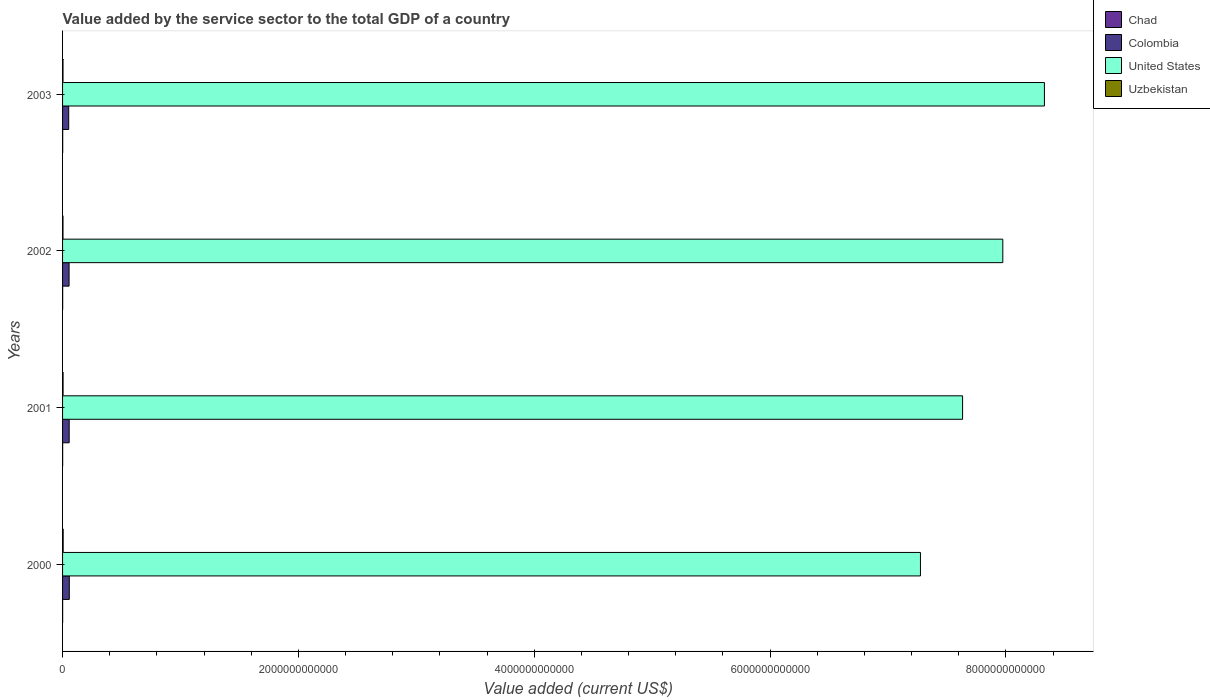How many different coloured bars are there?
Your answer should be compact. 4. How many groups of bars are there?
Your response must be concise. 4. Are the number of bars per tick equal to the number of legend labels?
Provide a short and direct response. Yes. Are the number of bars on each tick of the Y-axis equal?
Give a very brief answer. Yes. What is the value added by the service sector to the total GDP in Uzbekistan in 2002?
Ensure brevity in your answer.  3.72e+09. Across all years, what is the maximum value added by the service sector to the total GDP in United States?
Provide a succinct answer. 8.33e+12. Across all years, what is the minimum value added by the service sector to the total GDP in United States?
Make the answer very short. 7.28e+12. What is the total value added by the service sector to the total GDP in Uzbekistan in the graph?
Your answer should be very brief. 1.70e+1. What is the difference between the value added by the service sector to the total GDP in Chad in 2001 and that in 2003?
Ensure brevity in your answer.  -3.71e+08. What is the difference between the value added by the service sector to the total GDP in United States in 2003 and the value added by the service sector to the total GDP in Chad in 2002?
Keep it short and to the point. 8.33e+12. What is the average value added by the service sector to the total GDP in United States per year?
Make the answer very short. 7.80e+12. In the year 2000, what is the difference between the value added by the service sector to the total GDP in Chad and value added by the service sector to the total GDP in Colombia?
Provide a succinct answer. -5.65e+1. What is the ratio of the value added by the service sector to the total GDP in Colombia in 2002 to that in 2003?
Offer a very short reply. 1.06. Is the value added by the service sector to the total GDP in United States in 2002 less than that in 2003?
Make the answer very short. Yes. What is the difference between the highest and the second highest value added by the service sector to the total GDP in United States?
Give a very brief answer. 3.53e+11. What is the difference between the highest and the lowest value added by the service sector to the total GDP in Colombia?
Keep it short and to the point. 5.15e+09. In how many years, is the value added by the service sector to the total GDP in Chad greater than the average value added by the service sector to the total GDP in Chad taken over all years?
Your response must be concise. 2. Is it the case that in every year, the sum of the value added by the service sector to the total GDP in United States and value added by the service sector to the total GDP in Uzbekistan is greater than the sum of value added by the service sector to the total GDP in Colombia and value added by the service sector to the total GDP in Chad?
Provide a succinct answer. Yes. What does the 2nd bar from the top in 2002 represents?
Provide a succinct answer. United States. How many bars are there?
Offer a very short reply. 16. Are all the bars in the graph horizontal?
Your answer should be very brief. Yes. What is the difference between two consecutive major ticks on the X-axis?
Your answer should be compact. 2.00e+12. Does the graph contain any zero values?
Offer a terse response. No. Does the graph contain grids?
Your answer should be compact. No. Where does the legend appear in the graph?
Ensure brevity in your answer.  Top right. How many legend labels are there?
Provide a short and direct response. 4. What is the title of the graph?
Ensure brevity in your answer.  Value added by the service sector to the total GDP of a country. What is the label or title of the X-axis?
Give a very brief answer. Value added (current US$). What is the Value added (current US$) of Chad in 2000?
Keep it short and to the point. 6.17e+08. What is the Value added (current US$) in Colombia in 2000?
Your response must be concise. 5.71e+1. What is the Value added (current US$) of United States in 2000?
Keep it short and to the point. 7.28e+12. What is the Value added (current US$) of Uzbekistan in 2000?
Keep it short and to the point. 5.12e+09. What is the Value added (current US$) of Chad in 2001?
Your response must be concise. 7.35e+08. What is the Value added (current US$) of Colombia in 2001?
Ensure brevity in your answer.  5.61e+1. What is the Value added (current US$) of United States in 2001?
Your answer should be compact. 7.63e+12. What is the Value added (current US$) of Uzbekistan in 2001?
Offer a terse response. 4.36e+09. What is the Value added (current US$) of Chad in 2002?
Give a very brief answer. 8.73e+08. What is the Value added (current US$) of Colombia in 2002?
Your answer should be very brief. 5.53e+1. What is the Value added (current US$) of United States in 2002?
Your response must be concise. 7.97e+12. What is the Value added (current US$) of Uzbekistan in 2002?
Offer a terse response. 3.72e+09. What is the Value added (current US$) of Chad in 2003?
Provide a succinct answer. 1.11e+09. What is the Value added (current US$) of Colombia in 2003?
Keep it short and to the point. 5.20e+1. What is the Value added (current US$) in United States in 2003?
Keep it short and to the point. 8.33e+12. What is the Value added (current US$) of Uzbekistan in 2003?
Your answer should be compact. 3.79e+09. Across all years, what is the maximum Value added (current US$) in Chad?
Keep it short and to the point. 1.11e+09. Across all years, what is the maximum Value added (current US$) of Colombia?
Offer a very short reply. 5.71e+1. Across all years, what is the maximum Value added (current US$) of United States?
Keep it short and to the point. 8.33e+12. Across all years, what is the maximum Value added (current US$) in Uzbekistan?
Your answer should be compact. 5.12e+09. Across all years, what is the minimum Value added (current US$) in Chad?
Your answer should be very brief. 6.17e+08. Across all years, what is the minimum Value added (current US$) in Colombia?
Ensure brevity in your answer.  5.20e+1. Across all years, what is the minimum Value added (current US$) in United States?
Offer a terse response. 7.28e+12. Across all years, what is the minimum Value added (current US$) of Uzbekistan?
Your response must be concise. 3.72e+09. What is the total Value added (current US$) in Chad in the graph?
Give a very brief answer. 3.33e+09. What is the total Value added (current US$) of Colombia in the graph?
Give a very brief answer. 2.21e+11. What is the total Value added (current US$) of United States in the graph?
Offer a terse response. 3.12e+13. What is the total Value added (current US$) in Uzbekistan in the graph?
Provide a short and direct response. 1.70e+1. What is the difference between the Value added (current US$) in Chad in 2000 and that in 2001?
Give a very brief answer. -1.18e+08. What is the difference between the Value added (current US$) in Colombia in 2000 and that in 2001?
Ensure brevity in your answer.  9.92e+08. What is the difference between the Value added (current US$) in United States in 2000 and that in 2001?
Provide a succinct answer. -3.57e+11. What is the difference between the Value added (current US$) of Uzbekistan in 2000 and that in 2001?
Offer a terse response. 7.60e+08. What is the difference between the Value added (current US$) of Chad in 2000 and that in 2002?
Offer a terse response. -2.56e+08. What is the difference between the Value added (current US$) of Colombia in 2000 and that in 2002?
Make the answer very short. 1.84e+09. What is the difference between the Value added (current US$) of United States in 2000 and that in 2002?
Provide a short and direct response. -6.99e+11. What is the difference between the Value added (current US$) in Uzbekistan in 2000 and that in 2002?
Keep it short and to the point. 1.39e+09. What is the difference between the Value added (current US$) of Chad in 2000 and that in 2003?
Offer a terse response. -4.88e+08. What is the difference between the Value added (current US$) in Colombia in 2000 and that in 2003?
Your answer should be compact. 5.15e+09. What is the difference between the Value added (current US$) of United States in 2000 and that in 2003?
Keep it short and to the point. -1.05e+12. What is the difference between the Value added (current US$) in Uzbekistan in 2000 and that in 2003?
Your answer should be very brief. 1.32e+09. What is the difference between the Value added (current US$) in Chad in 2001 and that in 2002?
Provide a short and direct response. -1.38e+08. What is the difference between the Value added (current US$) in Colombia in 2001 and that in 2002?
Give a very brief answer. 8.46e+08. What is the difference between the Value added (current US$) of United States in 2001 and that in 2002?
Your answer should be compact. -3.41e+11. What is the difference between the Value added (current US$) of Uzbekistan in 2001 and that in 2002?
Provide a succinct answer. 6.34e+08. What is the difference between the Value added (current US$) in Chad in 2001 and that in 2003?
Offer a terse response. -3.71e+08. What is the difference between the Value added (current US$) in Colombia in 2001 and that in 2003?
Give a very brief answer. 4.15e+09. What is the difference between the Value added (current US$) in United States in 2001 and that in 2003?
Your answer should be very brief. -6.94e+11. What is the difference between the Value added (current US$) in Uzbekistan in 2001 and that in 2003?
Provide a succinct answer. 5.64e+08. What is the difference between the Value added (current US$) of Chad in 2002 and that in 2003?
Offer a very short reply. -2.32e+08. What is the difference between the Value added (current US$) in Colombia in 2002 and that in 2003?
Ensure brevity in your answer.  3.31e+09. What is the difference between the Value added (current US$) in United States in 2002 and that in 2003?
Provide a succinct answer. -3.53e+11. What is the difference between the Value added (current US$) of Uzbekistan in 2002 and that in 2003?
Your response must be concise. -6.96e+07. What is the difference between the Value added (current US$) of Chad in 2000 and the Value added (current US$) of Colombia in 2001?
Your answer should be compact. -5.55e+1. What is the difference between the Value added (current US$) in Chad in 2000 and the Value added (current US$) in United States in 2001?
Offer a terse response. -7.63e+12. What is the difference between the Value added (current US$) in Chad in 2000 and the Value added (current US$) in Uzbekistan in 2001?
Your answer should be very brief. -3.74e+09. What is the difference between the Value added (current US$) of Colombia in 2000 and the Value added (current US$) of United States in 2001?
Offer a terse response. -7.58e+12. What is the difference between the Value added (current US$) of Colombia in 2000 and the Value added (current US$) of Uzbekistan in 2001?
Give a very brief answer. 5.28e+1. What is the difference between the Value added (current US$) of United States in 2000 and the Value added (current US$) of Uzbekistan in 2001?
Make the answer very short. 7.27e+12. What is the difference between the Value added (current US$) in Chad in 2000 and the Value added (current US$) in Colombia in 2002?
Offer a terse response. -5.47e+1. What is the difference between the Value added (current US$) in Chad in 2000 and the Value added (current US$) in United States in 2002?
Provide a succinct answer. -7.97e+12. What is the difference between the Value added (current US$) in Chad in 2000 and the Value added (current US$) in Uzbekistan in 2002?
Make the answer very short. -3.11e+09. What is the difference between the Value added (current US$) in Colombia in 2000 and the Value added (current US$) in United States in 2002?
Provide a succinct answer. -7.92e+12. What is the difference between the Value added (current US$) in Colombia in 2000 and the Value added (current US$) in Uzbekistan in 2002?
Your response must be concise. 5.34e+1. What is the difference between the Value added (current US$) in United States in 2000 and the Value added (current US$) in Uzbekistan in 2002?
Your response must be concise. 7.27e+12. What is the difference between the Value added (current US$) in Chad in 2000 and the Value added (current US$) in Colombia in 2003?
Make the answer very short. -5.14e+1. What is the difference between the Value added (current US$) in Chad in 2000 and the Value added (current US$) in United States in 2003?
Your response must be concise. -8.33e+12. What is the difference between the Value added (current US$) of Chad in 2000 and the Value added (current US$) of Uzbekistan in 2003?
Your answer should be compact. -3.18e+09. What is the difference between the Value added (current US$) in Colombia in 2000 and the Value added (current US$) in United States in 2003?
Provide a succinct answer. -8.27e+12. What is the difference between the Value added (current US$) in Colombia in 2000 and the Value added (current US$) in Uzbekistan in 2003?
Your response must be concise. 5.33e+1. What is the difference between the Value added (current US$) in United States in 2000 and the Value added (current US$) in Uzbekistan in 2003?
Provide a short and direct response. 7.27e+12. What is the difference between the Value added (current US$) in Chad in 2001 and the Value added (current US$) in Colombia in 2002?
Keep it short and to the point. -5.46e+1. What is the difference between the Value added (current US$) in Chad in 2001 and the Value added (current US$) in United States in 2002?
Offer a terse response. -7.97e+12. What is the difference between the Value added (current US$) in Chad in 2001 and the Value added (current US$) in Uzbekistan in 2002?
Provide a succinct answer. -2.99e+09. What is the difference between the Value added (current US$) in Colombia in 2001 and the Value added (current US$) in United States in 2002?
Provide a succinct answer. -7.92e+12. What is the difference between the Value added (current US$) of Colombia in 2001 and the Value added (current US$) of Uzbekistan in 2002?
Keep it short and to the point. 5.24e+1. What is the difference between the Value added (current US$) in United States in 2001 and the Value added (current US$) in Uzbekistan in 2002?
Provide a succinct answer. 7.63e+12. What is the difference between the Value added (current US$) in Chad in 2001 and the Value added (current US$) in Colombia in 2003?
Offer a very short reply. -5.12e+1. What is the difference between the Value added (current US$) in Chad in 2001 and the Value added (current US$) in United States in 2003?
Provide a short and direct response. -8.33e+12. What is the difference between the Value added (current US$) in Chad in 2001 and the Value added (current US$) in Uzbekistan in 2003?
Give a very brief answer. -3.06e+09. What is the difference between the Value added (current US$) of Colombia in 2001 and the Value added (current US$) of United States in 2003?
Make the answer very short. -8.27e+12. What is the difference between the Value added (current US$) in Colombia in 2001 and the Value added (current US$) in Uzbekistan in 2003?
Your response must be concise. 5.23e+1. What is the difference between the Value added (current US$) in United States in 2001 and the Value added (current US$) in Uzbekistan in 2003?
Give a very brief answer. 7.63e+12. What is the difference between the Value added (current US$) of Chad in 2002 and the Value added (current US$) of Colombia in 2003?
Your answer should be very brief. -5.11e+1. What is the difference between the Value added (current US$) in Chad in 2002 and the Value added (current US$) in United States in 2003?
Provide a short and direct response. -8.33e+12. What is the difference between the Value added (current US$) in Chad in 2002 and the Value added (current US$) in Uzbekistan in 2003?
Provide a short and direct response. -2.92e+09. What is the difference between the Value added (current US$) of Colombia in 2002 and the Value added (current US$) of United States in 2003?
Your answer should be compact. -8.27e+12. What is the difference between the Value added (current US$) in Colombia in 2002 and the Value added (current US$) in Uzbekistan in 2003?
Offer a very short reply. 5.15e+1. What is the difference between the Value added (current US$) in United States in 2002 and the Value added (current US$) in Uzbekistan in 2003?
Your answer should be compact. 7.97e+12. What is the average Value added (current US$) in Chad per year?
Your answer should be very brief. 8.33e+08. What is the average Value added (current US$) in Colombia per year?
Your answer should be very brief. 5.51e+1. What is the average Value added (current US$) in United States per year?
Your answer should be compact. 7.80e+12. What is the average Value added (current US$) in Uzbekistan per year?
Offer a very short reply. 4.25e+09. In the year 2000, what is the difference between the Value added (current US$) in Chad and Value added (current US$) in Colombia?
Make the answer very short. -5.65e+1. In the year 2000, what is the difference between the Value added (current US$) in Chad and Value added (current US$) in United States?
Provide a succinct answer. -7.27e+12. In the year 2000, what is the difference between the Value added (current US$) in Chad and Value added (current US$) in Uzbekistan?
Your answer should be very brief. -4.50e+09. In the year 2000, what is the difference between the Value added (current US$) in Colombia and Value added (current US$) in United States?
Offer a very short reply. -7.22e+12. In the year 2000, what is the difference between the Value added (current US$) in Colombia and Value added (current US$) in Uzbekistan?
Your response must be concise. 5.20e+1. In the year 2000, what is the difference between the Value added (current US$) of United States and Value added (current US$) of Uzbekistan?
Provide a short and direct response. 7.27e+12. In the year 2001, what is the difference between the Value added (current US$) of Chad and Value added (current US$) of Colombia?
Make the answer very short. -5.54e+1. In the year 2001, what is the difference between the Value added (current US$) in Chad and Value added (current US$) in United States?
Make the answer very short. -7.63e+12. In the year 2001, what is the difference between the Value added (current US$) in Chad and Value added (current US$) in Uzbekistan?
Keep it short and to the point. -3.62e+09. In the year 2001, what is the difference between the Value added (current US$) of Colombia and Value added (current US$) of United States?
Give a very brief answer. -7.58e+12. In the year 2001, what is the difference between the Value added (current US$) in Colombia and Value added (current US$) in Uzbekistan?
Your answer should be compact. 5.18e+1. In the year 2001, what is the difference between the Value added (current US$) of United States and Value added (current US$) of Uzbekistan?
Provide a short and direct response. 7.63e+12. In the year 2002, what is the difference between the Value added (current US$) of Chad and Value added (current US$) of Colombia?
Offer a very short reply. -5.44e+1. In the year 2002, what is the difference between the Value added (current US$) in Chad and Value added (current US$) in United States?
Ensure brevity in your answer.  -7.97e+12. In the year 2002, what is the difference between the Value added (current US$) of Chad and Value added (current US$) of Uzbekistan?
Provide a succinct answer. -2.85e+09. In the year 2002, what is the difference between the Value added (current US$) of Colombia and Value added (current US$) of United States?
Your answer should be very brief. -7.92e+12. In the year 2002, what is the difference between the Value added (current US$) in Colombia and Value added (current US$) in Uzbekistan?
Provide a short and direct response. 5.16e+1. In the year 2002, what is the difference between the Value added (current US$) of United States and Value added (current US$) of Uzbekistan?
Your answer should be compact. 7.97e+12. In the year 2003, what is the difference between the Value added (current US$) in Chad and Value added (current US$) in Colombia?
Offer a very short reply. -5.09e+1. In the year 2003, what is the difference between the Value added (current US$) of Chad and Value added (current US$) of United States?
Ensure brevity in your answer.  -8.33e+12. In the year 2003, what is the difference between the Value added (current US$) in Chad and Value added (current US$) in Uzbekistan?
Offer a terse response. -2.69e+09. In the year 2003, what is the difference between the Value added (current US$) of Colombia and Value added (current US$) of United States?
Offer a very short reply. -8.27e+12. In the year 2003, what is the difference between the Value added (current US$) in Colombia and Value added (current US$) in Uzbekistan?
Offer a very short reply. 4.82e+1. In the year 2003, what is the difference between the Value added (current US$) in United States and Value added (current US$) in Uzbekistan?
Keep it short and to the point. 8.32e+12. What is the ratio of the Value added (current US$) in Chad in 2000 to that in 2001?
Your answer should be compact. 0.84. What is the ratio of the Value added (current US$) in Colombia in 2000 to that in 2001?
Offer a very short reply. 1.02. What is the ratio of the Value added (current US$) in United States in 2000 to that in 2001?
Your response must be concise. 0.95. What is the ratio of the Value added (current US$) of Uzbekistan in 2000 to that in 2001?
Offer a very short reply. 1.17. What is the ratio of the Value added (current US$) in Chad in 2000 to that in 2002?
Your answer should be very brief. 0.71. What is the ratio of the Value added (current US$) in Colombia in 2000 to that in 2002?
Your response must be concise. 1.03. What is the ratio of the Value added (current US$) in United States in 2000 to that in 2002?
Keep it short and to the point. 0.91. What is the ratio of the Value added (current US$) in Uzbekistan in 2000 to that in 2002?
Your answer should be very brief. 1.37. What is the ratio of the Value added (current US$) in Chad in 2000 to that in 2003?
Give a very brief answer. 0.56. What is the ratio of the Value added (current US$) of Colombia in 2000 to that in 2003?
Keep it short and to the point. 1.1. What is the ratio of the Value added (current US$) in United States in 2000 to that in 2003?
Your answer should be very brief. 0.87. What is the ratio of the Value added (current US$) in Uzbekistan in 2000 to that in 2003?
Ensure brevity in your answer.  1.35. What is the ratio of the Value added (current US$) of Chad in 2001 to that in 2002?
Your answer should be very brief. 0.84. What is the ratio of the Value added (current US$) of Colombia in 2001 to that in 2002?
Your response must be concise. 1.02. What is the ratio of the Value added (current US$) in United States in 2001 to that in 2002?
Provide a succinct answer. 0.96. What is the ratio of the Value added (current US$) of Uzbekistan in 2001 to that in 2002?
Offer a very short reply. 1.17. What is the ratio of the Value added (current US$) of Chad in 2001 to that in 2003?
Your answer should be compact. 0.66. What is the ratio of the Value added (current US$) in Colombia in 2001 to that in 2003?
Your answer should be very brief. 1.08. What is the ratio of the Value added (current US$) of Uzbekistan in 2001 to that in 2003?
Your response must be concise. 1.15. What is the ratio of the Value added (current US$) of Chad in 2002 to that in 2003?
Ensure brevity in your answer.  0.79. What is the ratio of the Value added (current US$) in Colombia in 2002 to that in 2003?
Provide a short and direct response. 1.06. What is the ratio of the Value added (current US$) in United States in 2002 to that in 2003?
Your answer should be compact. 0.96. What is the ratio of the Value added (current US$) of Uzbekistan in 2002 to that in 2003?
Ensure brevity in your answer.  0.98. What is the difference between the highest and the second highest Value added (current US$) of Chad?
Your answer should be compact. 2.32e+08. What is the difference between the highest and the second highest Value added (current US$) in Colombia?
Your answer should be compact. 9.92e+08. What is the difference between the highest and the second highest Value added (current US$) of United States?
Your answer should be very brief. 3.53e+11. What is the difference between the highest and the second highest Value added (current US$) of Uzbekistan?
Your response must be concise. 7.60e+08. What is the difference between the highest and the lowest Value added (current US$) of Chad?
Provide a succinct answer. 4.88e+08. What is the difference between the highest and the lowest Value added (current US$) in Colombia?
Offer a very short reply. 5.15e+09. What is the difference between the highest and the lowest Value added (current US$) of United States?
Give a very brief answer. 1.05e+12. What is the difference between the highest and the lowest Value added (current US$) of Uzbekistan?
Provide a short and direct response. 1.39e+09. 